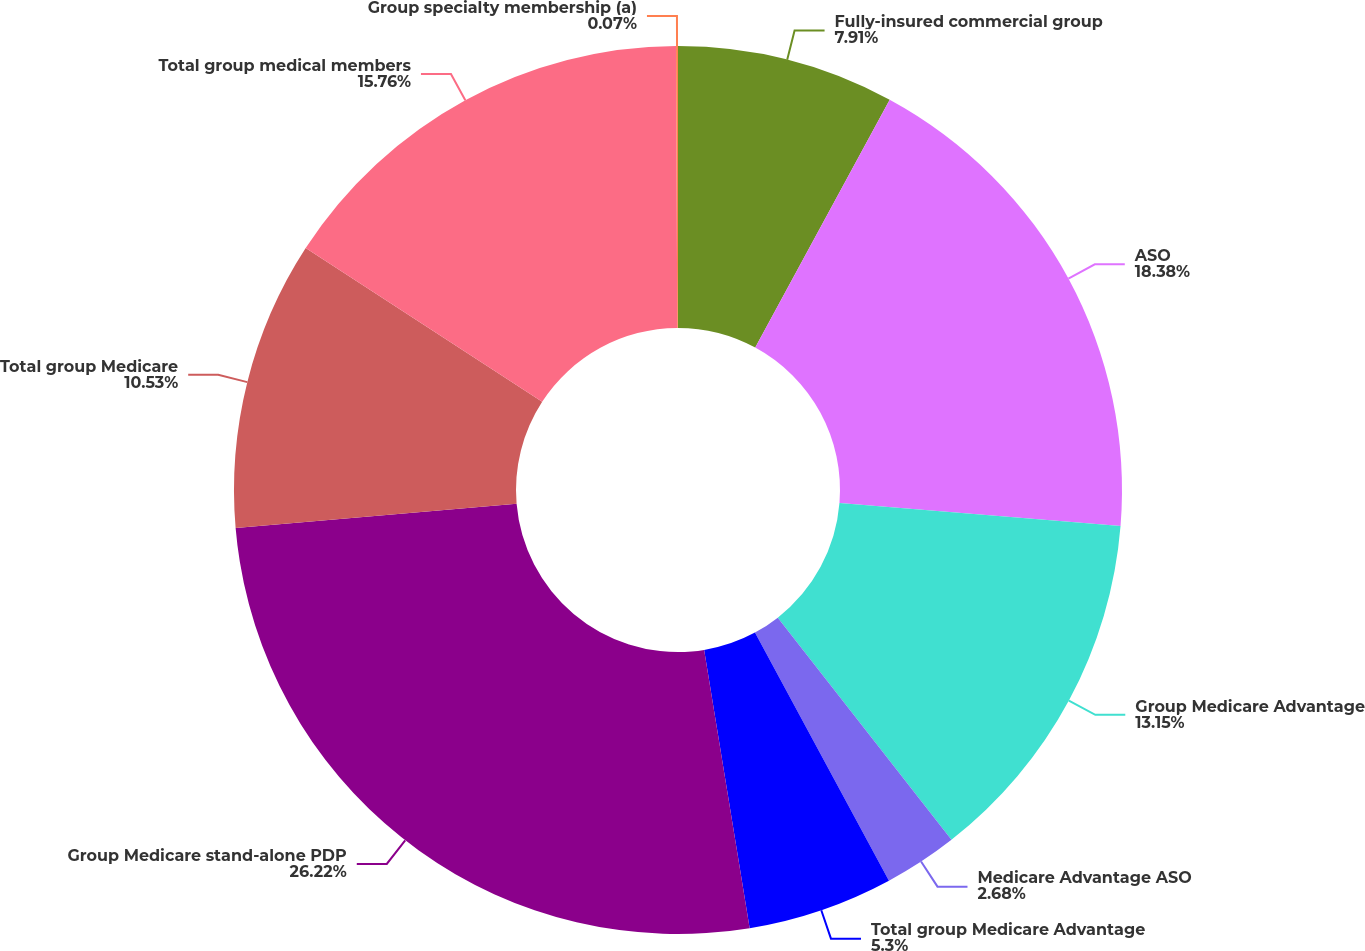<chart> <loc_0><loc_0><loc_500><loc_500><pie_chart><fcel>Fully-insured commercial group<fcel>ASO<fcel>Group Medicare Advantage<fcel>Medicare Advantage ASO<fcel>Total group Medicare Advantage<fcel>Group Medicare stand-alone PDP<fcel>Total group Medicare<fcel>Total group medical members<fcel>Group specialty membership (a)<nl><fcel>7.91%<fcel>18.38%<fcel>13.15%<fcel>2.68%<fcel>5.3%<fcel>26.22%<fcel>10.53%<fcel>15.76%<fcel>0.07%<nl></chart> 